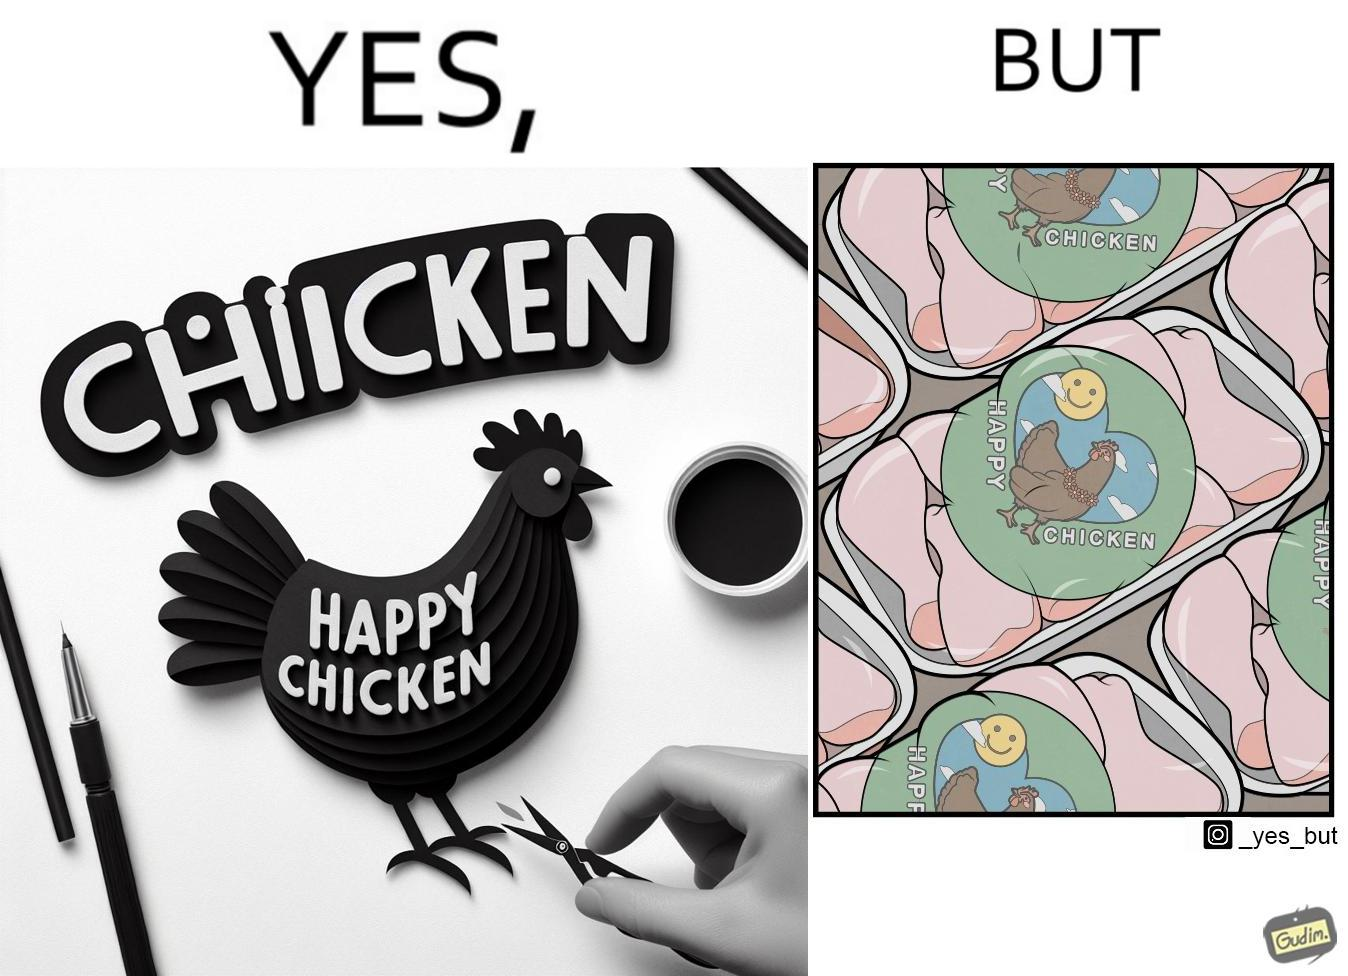Describe the contrast between the left and right parts of this image. In the left part of the image: a chicken with a quote "HAPPY CHICKEN" in the background In the right part of the image: chicken pieces packed in boxes with a logo of a chicken with name "HAPPY CHICKEN" printed on it 